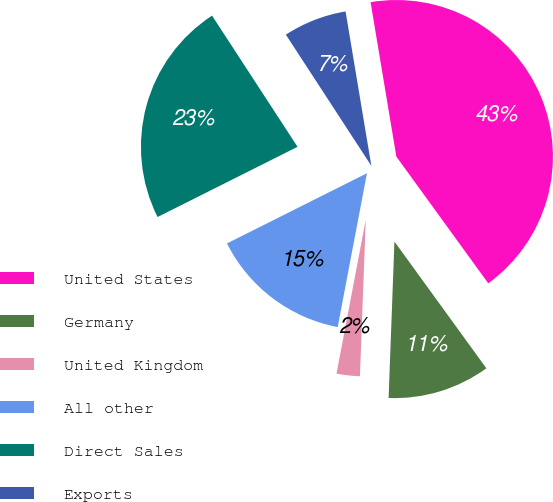Convert chart to OTSL. <chart><loc_0><loc_0><loc_500><loc_500><pie_chart><fcel>United States<fcel>Germany<fcel>United Kingdom<fcel>All other<fcel>Direct Sales<fcel>Exports<nl><fcel>42.65%<fcel>10.58%<fcel>2.4%<fcel>14.61%<fcel>23.21%<fcel>6.56%<nl></chart> 